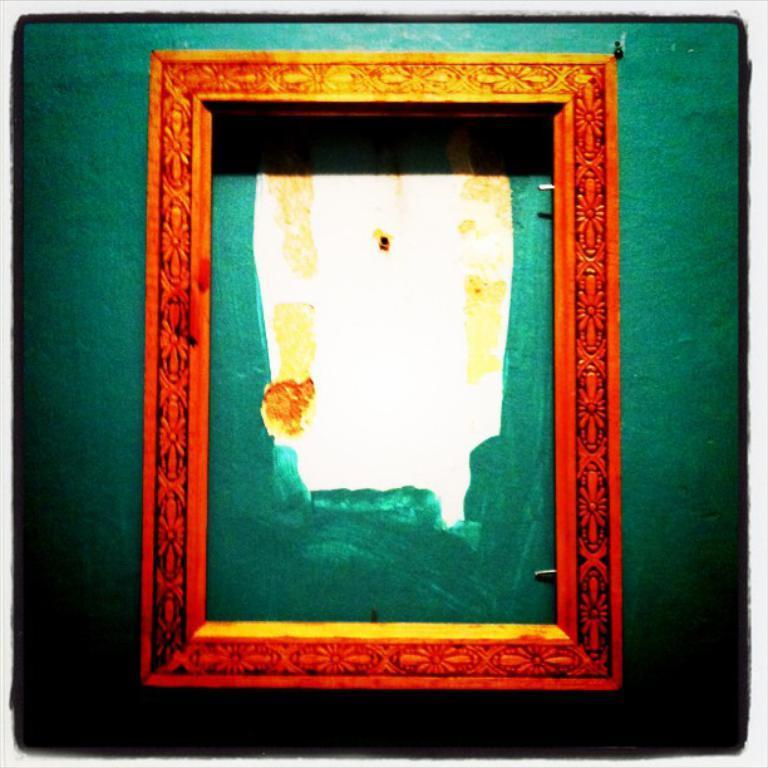Please provide a concise description of this image. In this image I can see a red color frame is attached to the wall. 